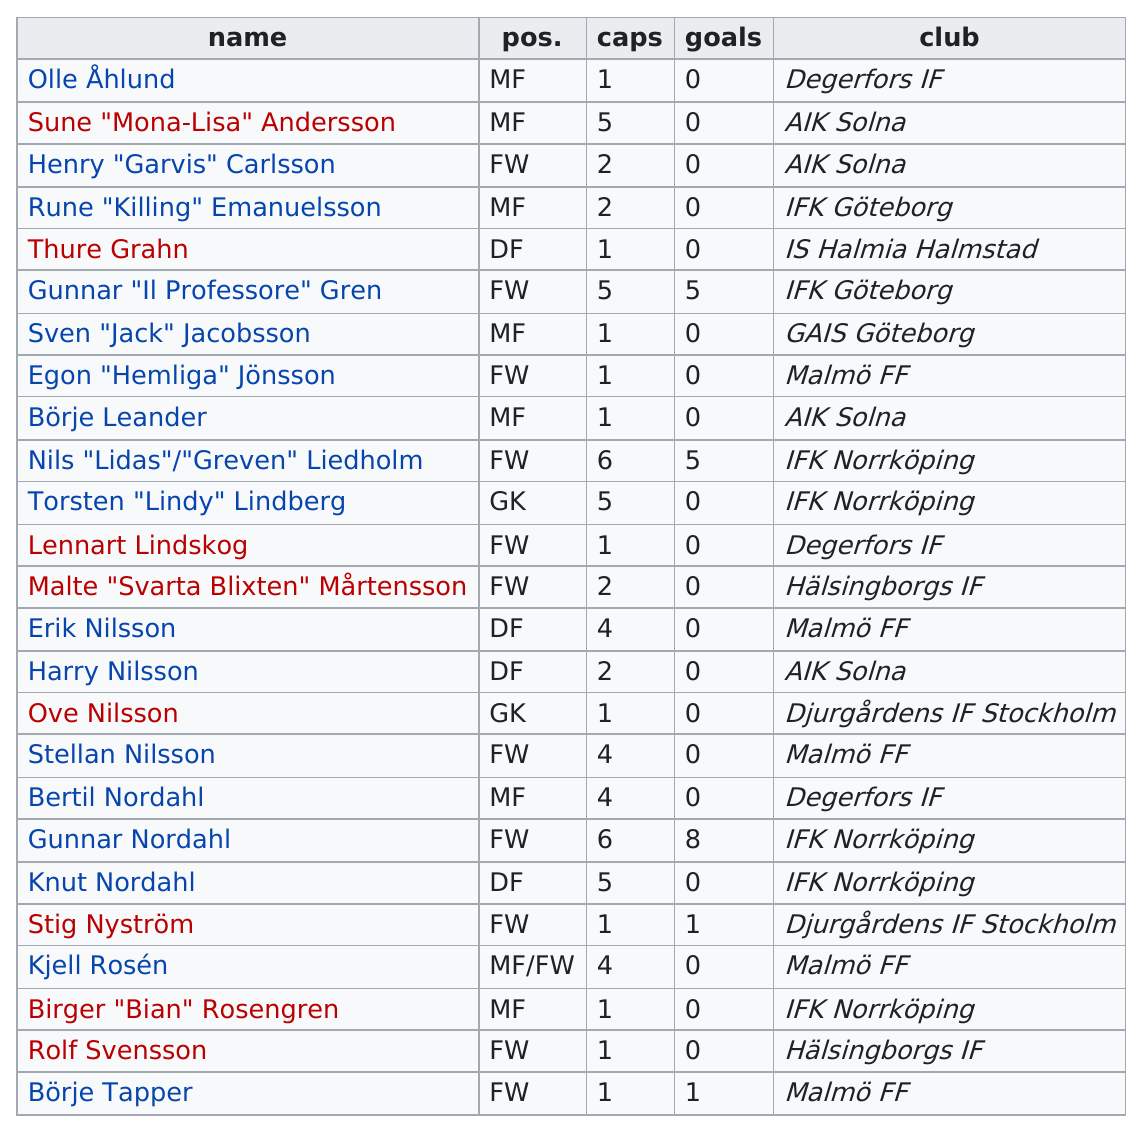Indicate a few pertinent items in this graphic. It is estimated that 15 people or fewer have fewer than 3 caps. At least 5 goals were scored by Gunnar "Il Professore" Gren, Nils "Lidas"/"Greven" Liedholm, and Gunnar Nordahl. There are 11 players whose last name ends in "son. I played on the same team as Rune "Killing" Emanuelsson, and my teammate Gunnar "Il Professore" Gren was also a formidable player. The nickname 'Mona-Lisa' is being referred to as 'Mona-Lisa' Andersson. 